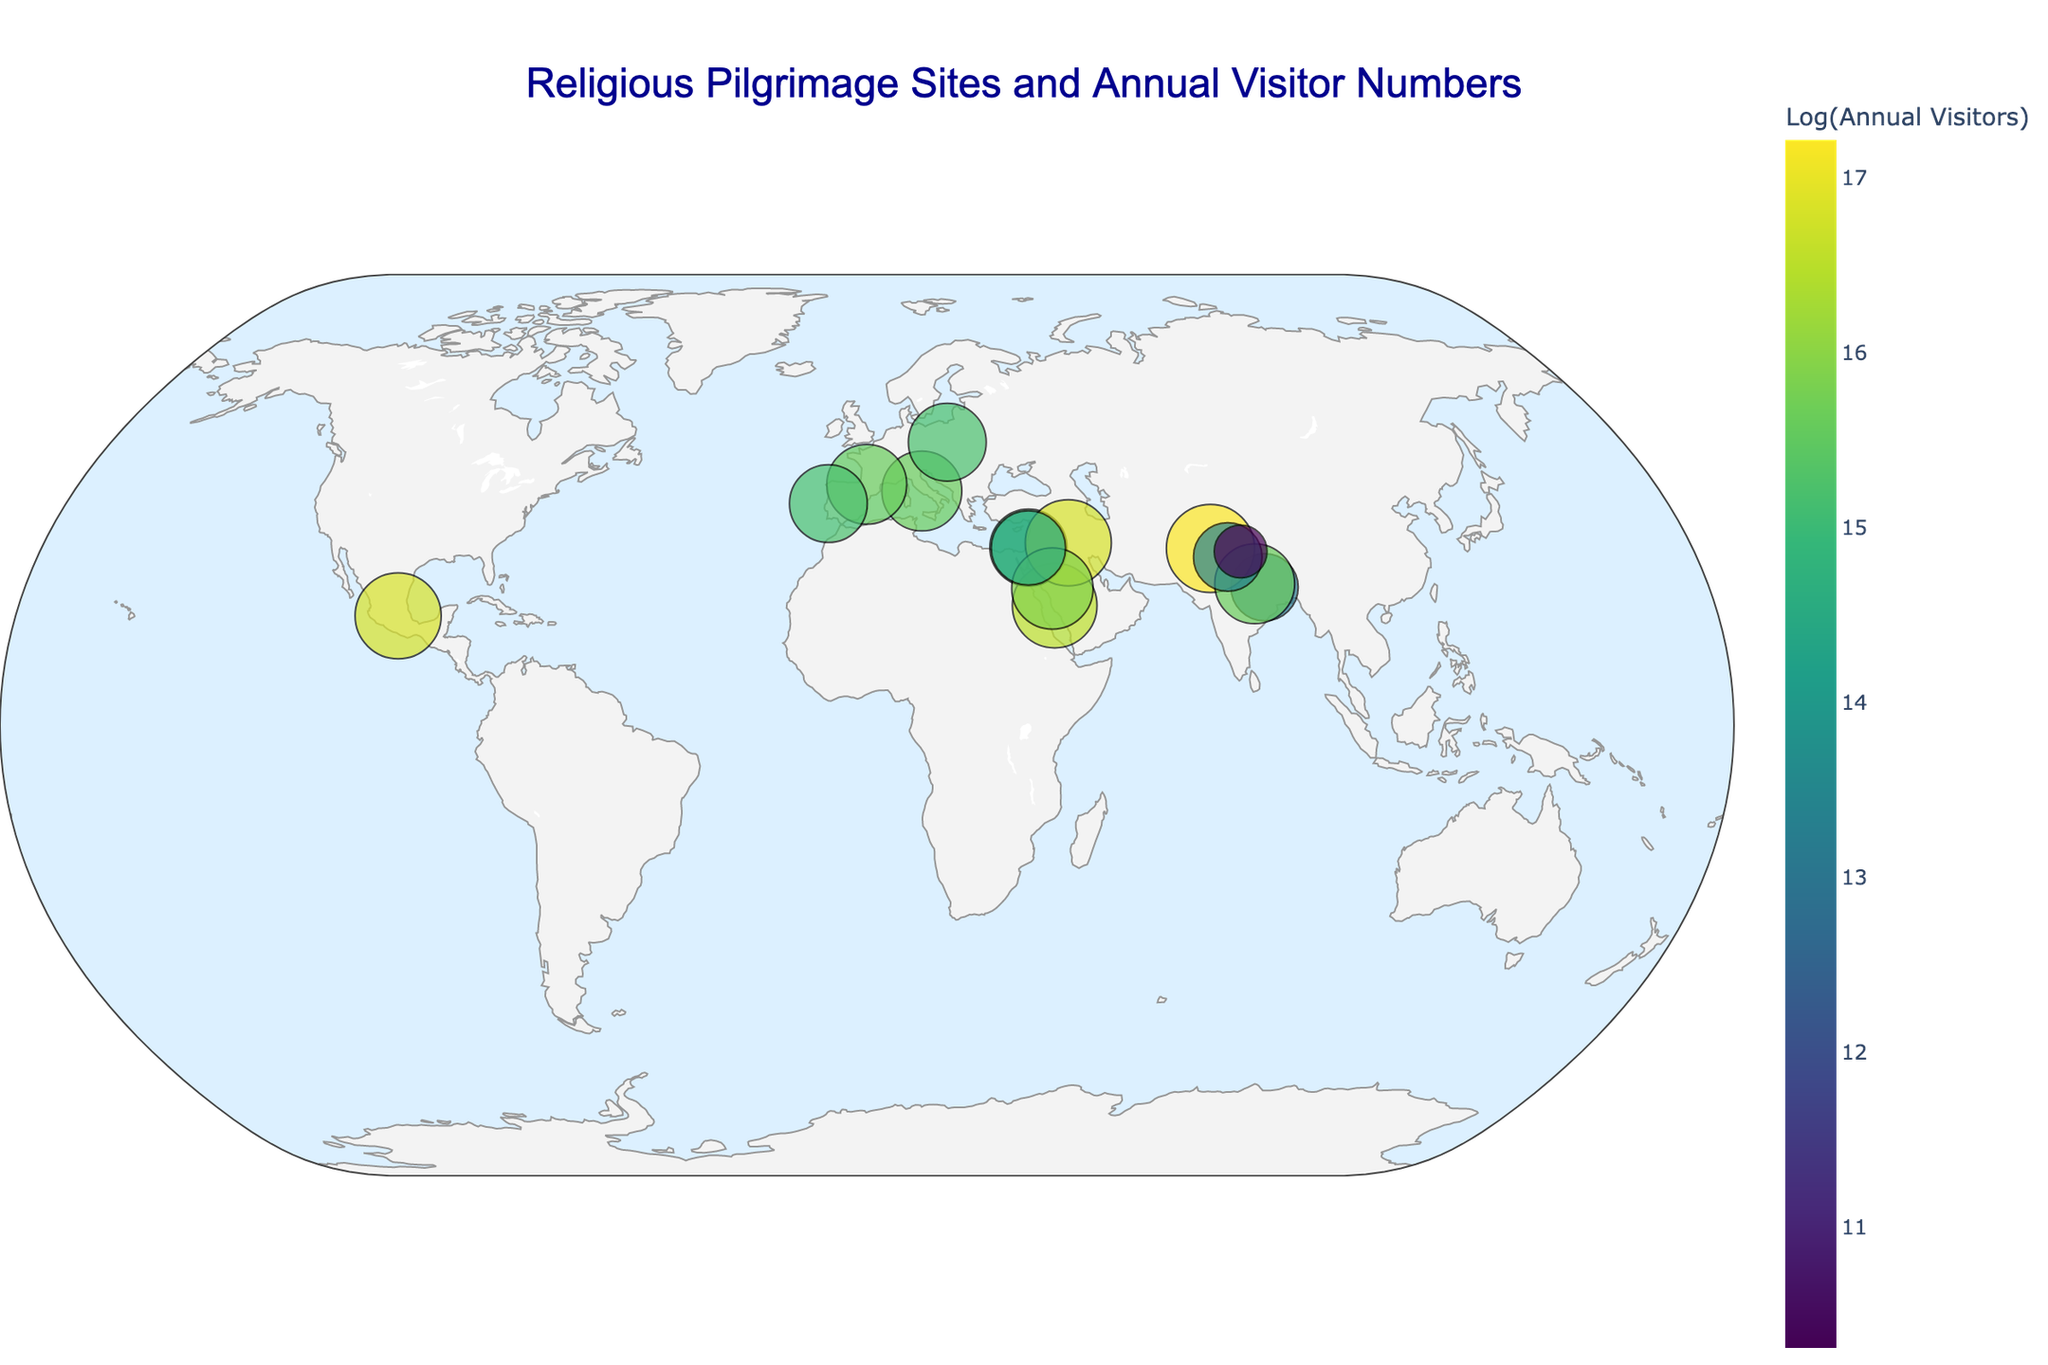How many unique pilgrimage sites are marked on the map? Count the number of unique sites listed in the data; each corresponds to a marker on the map.
Answer: 15 Which site has the highest number of annual visitors? By checking the annotations with visitor numbers, identify "Amritsar, India" with 30,000,000 visitors as the highest.
Answer: Amritsar, India Rank the top three pilgrimage sites by annual visitors. Sort the locations based on visitor numbers: Amritsar, India (30,000,000), Mecca, Saudi Arabia (15,000,000), Karbala, Iraq and Guadalupe, Mexico (20,000,000 each).
Answer: Amritsar, Mecca, Karbala/Guadalupe Which site is located closest to the equator? Identify the site with the latitude closest to zero. "Guadalupe, Mexico" with a latitude of 19.5922 is closest.
Answer: Guadalupe, Mexico Compare the number of annual visitors to Mecca, Saudi Arabia, and Vatican City, Italy. Which site has more? Check both sites' visitor numbers: Mecca has 15,000,000, and Vatican City has 6,000,000. Mecca has more visitors.
Answer: Mecca, Saudi Arabia What is the average number of annual visitors for the sites in India? Identify sites in India (Bodh Gaya, Amritsar, Varanasi, and Rishikesh), sum their visitors (500,000 + 30,000,000 + 6,000,000 + 650,000 = 37,150,000), then divide by the number of sites (4) for the average.
Answer: 9,287,500 Which continent has the most pilgrimage sites listed? By noting countries, Asia (Saudi Arabia, Israel, India, Iraq, China) seems to have the most with 8 sites.
Answer: Asia Which pilgrimage site is marked with the smallest marker on the map, and why? The smallest marker represents "Mount Kailash, China" due to its smallest number of annual visitors (30,000).
Answer: Mount Kailash, China What color range represents the highest number of visitors in the color scale? The "Viridis" color scale is used; darker colors typically represent higher visitor counts. So, the deeper colors at the top of the color bar indicate higher visitors.
Answer: Darker colors For the sites in Israel and Palestine, combined, how many annual visitors do they attract? Sum the visitors for Jerusalem (3,500,000) and Bethlehem (2,000,000): 3,500,000 + 2,000,000 = 5,500,000.
Answer: 5,500,000 